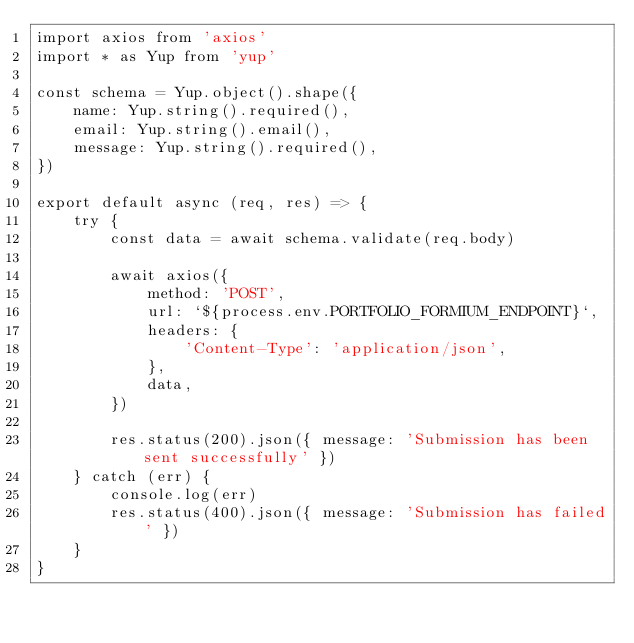Convert code to text. <code><loc_0><loc_0><loc_500><loc_500><_JavaScript_>import axios from 'axios'
import * as Yup from 'yup'

const schema = Yup.object().shape({
	name: Yup.string().required(),
	email: Yup.string().email(),
	message: Yup.string().required(),
})

export default async (req, res) => {
	try {
		const data = await schema.validate(req.body)

		await axios({
			method: 'POST',
			url: `${process.env.PORTFOLIO_FORMIUM_ENDPOINT}`,
			headers: {
				'Content-Type': 'application/json',
			},
			data,
		})

		res.status(200).json({ message: 'Submission has been sent successfully' })
	} catch (err) {
		console.log(err)
		res.status(400).json({ message: 'Submission has failed' })
	}
}
</code> 